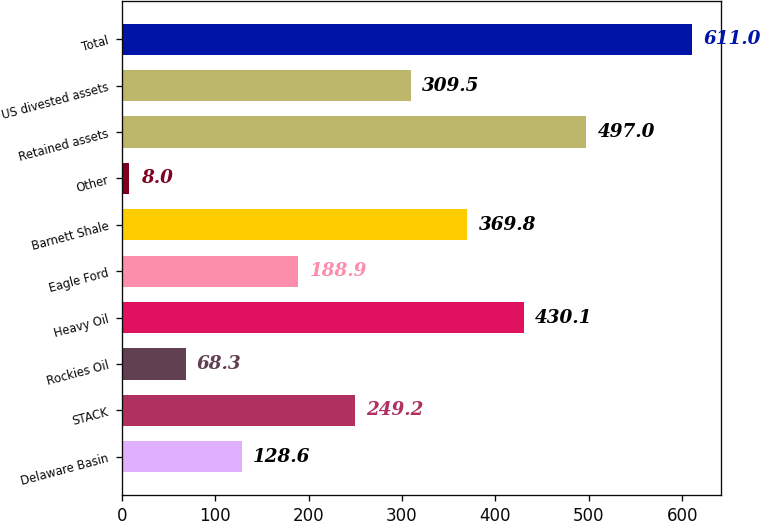Convert chart to OTSL. <chart><loc_0><loc_0><loc_500><loc_500><bar_chart><fcel>Delaware Basin<fcel>STACK<fcel>Rockies Oil<fcel>Heavy Oil<fcel>Eagle Ford<fcel>Barnett Shale<fcel>Other<fcel>Retained assets<fcel>US divested assets<fcel>Total<nl><fcel>128.6<fcel>249.2<fcel>68.3<fcel>430.1<fcel>188.9<fcel>369.8<fcel>8<fcel>497<fcel>309.5<fcel>611<nl></chart> 